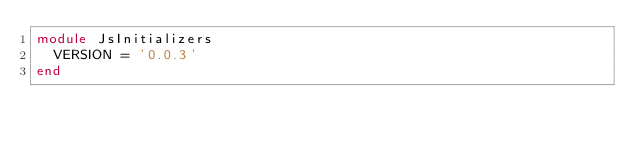Convert code to text. <code><loc_0><loc_0><loc_500><loc_500><_Ruby_>module JsInitializers
  VERSION = '0.0.3'
end
</code> 